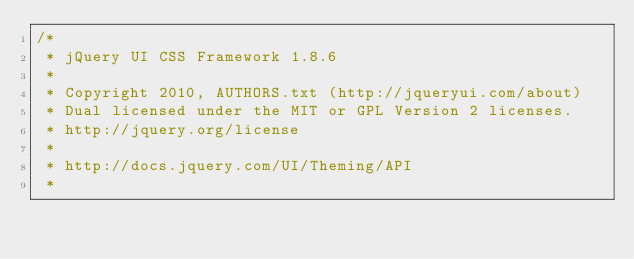Convert code to text. <code><loc_0><loc_0><loc_500><loc_500><_CSS_>/*
 * jQuery UI CSS Framework 1.8.6
 *
 * Copyright 2010, AUTHORS.txt (http://jqueryui.com/about)
 * Dual licensed under the MIT or GPL Version 2 licenses.
 * http://jquery.org/license
 *
 * http://docs.jquery.com/UI/Theming/API
 *</code> 